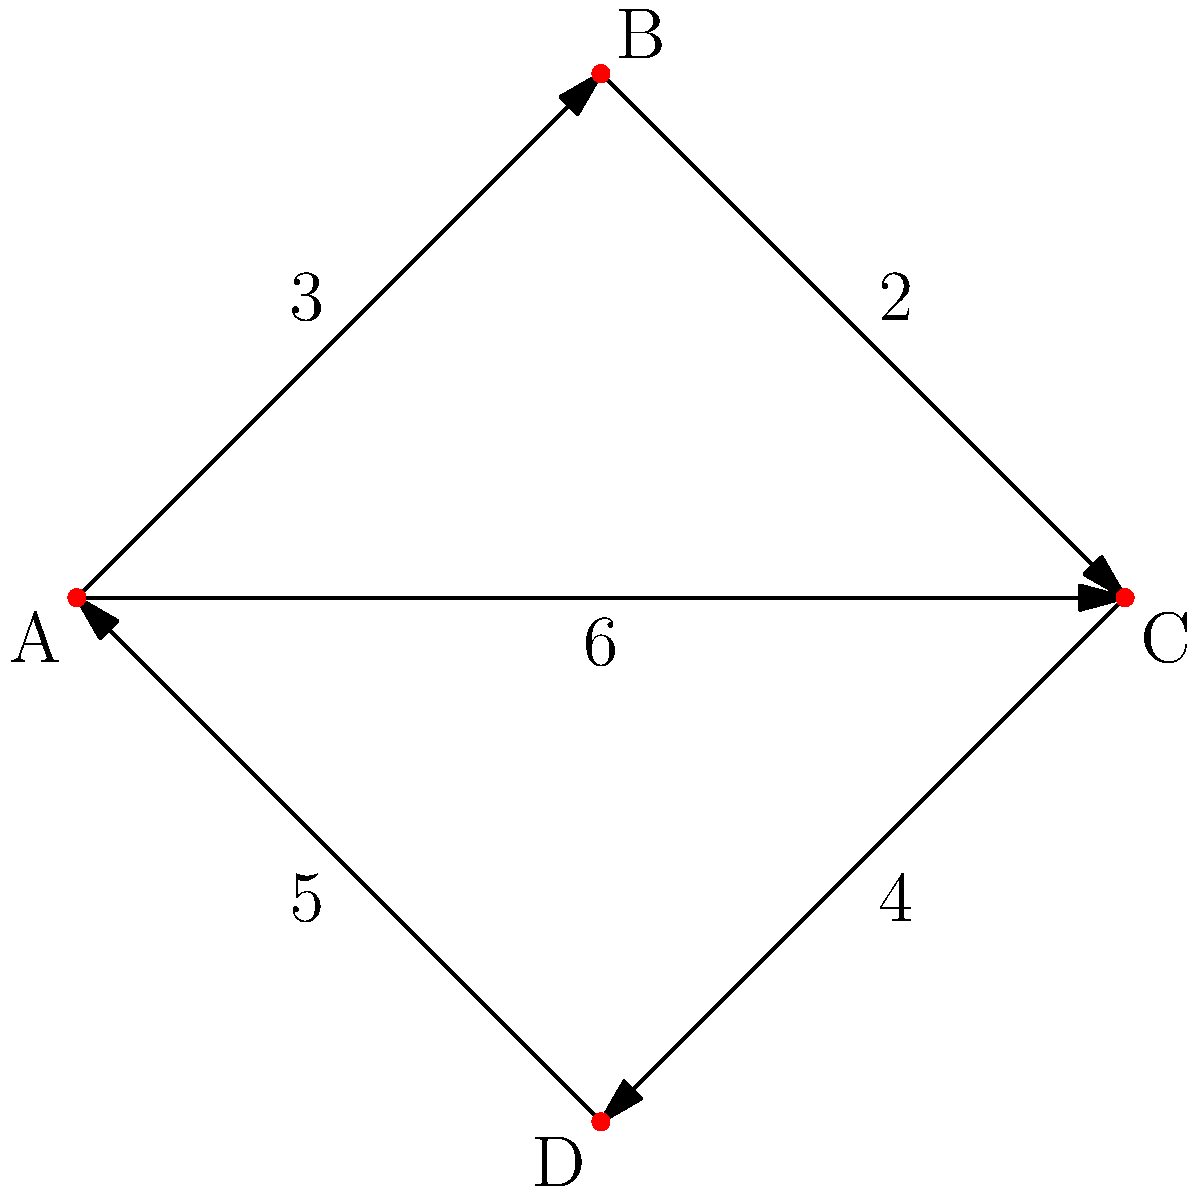In the network diagram above, each node represents a popular tourist spot in Sikkim, and the edges represent the travel time (in hours) between them. What is the shortest time required to travel from point A to point C? To find the shortest path from A to C, we need to consider all possible routes and their total travel times:

1. Path A → B → C:
   Time = 3 + 2 = 5 hours

2. Path A → C (direct):
   Time = 6 hours

3. Path A → D → C:
   Time = 5 + 4 = 9 hours

Comparing these times:
- Path 1: 5 hours
- Path 2: 6 hours
- Path 3: 9 hours

The shortest time is 5 hours, which is achieved by taking the path A → B → C.
Answer: 5 hours 